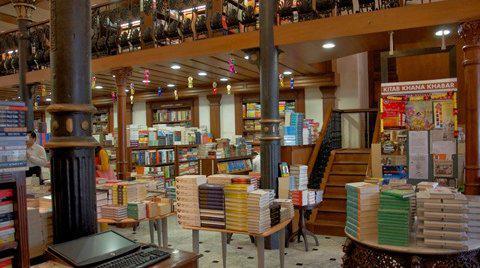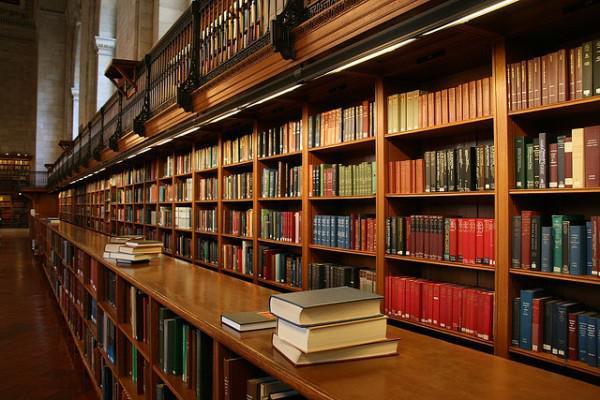The first image is the image on the left, the second image is the image on the right. For the images shown, is this caption "Next to at least 4 stacks of books there are two black poles painted gold towards the middle." true? Answer yes or no. Yes. The first image is the image on the left, the second image is the image on the right. For the images displayed, is the sentence "A sign with the name of the bookstore hangs over the store's entrance." factually correct? Answer yes or no. No. 